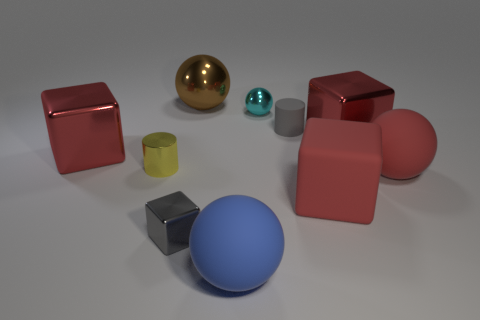Subtract all red cubes. How many were subtracted if there are1red cubes left? 2 Subtract all cyan spheres. How many red blocks are left? 3 Subtract 1 balls. How many balls are left? 3 Subtract all red balls. Subtract all purple cylinders. How many balls are left? 3 Subtract all cubes. How many objects are left? 6 Subtract all large cubes. Subtract all yellow metal objects. How many objects are left? 6 Add 3 blue matte things. How many blue matte things are left? 4 Add 3 tiny things. How many tiny things exist? 7 Subtract 1 yellow cylinders. How many objects are left? 9 